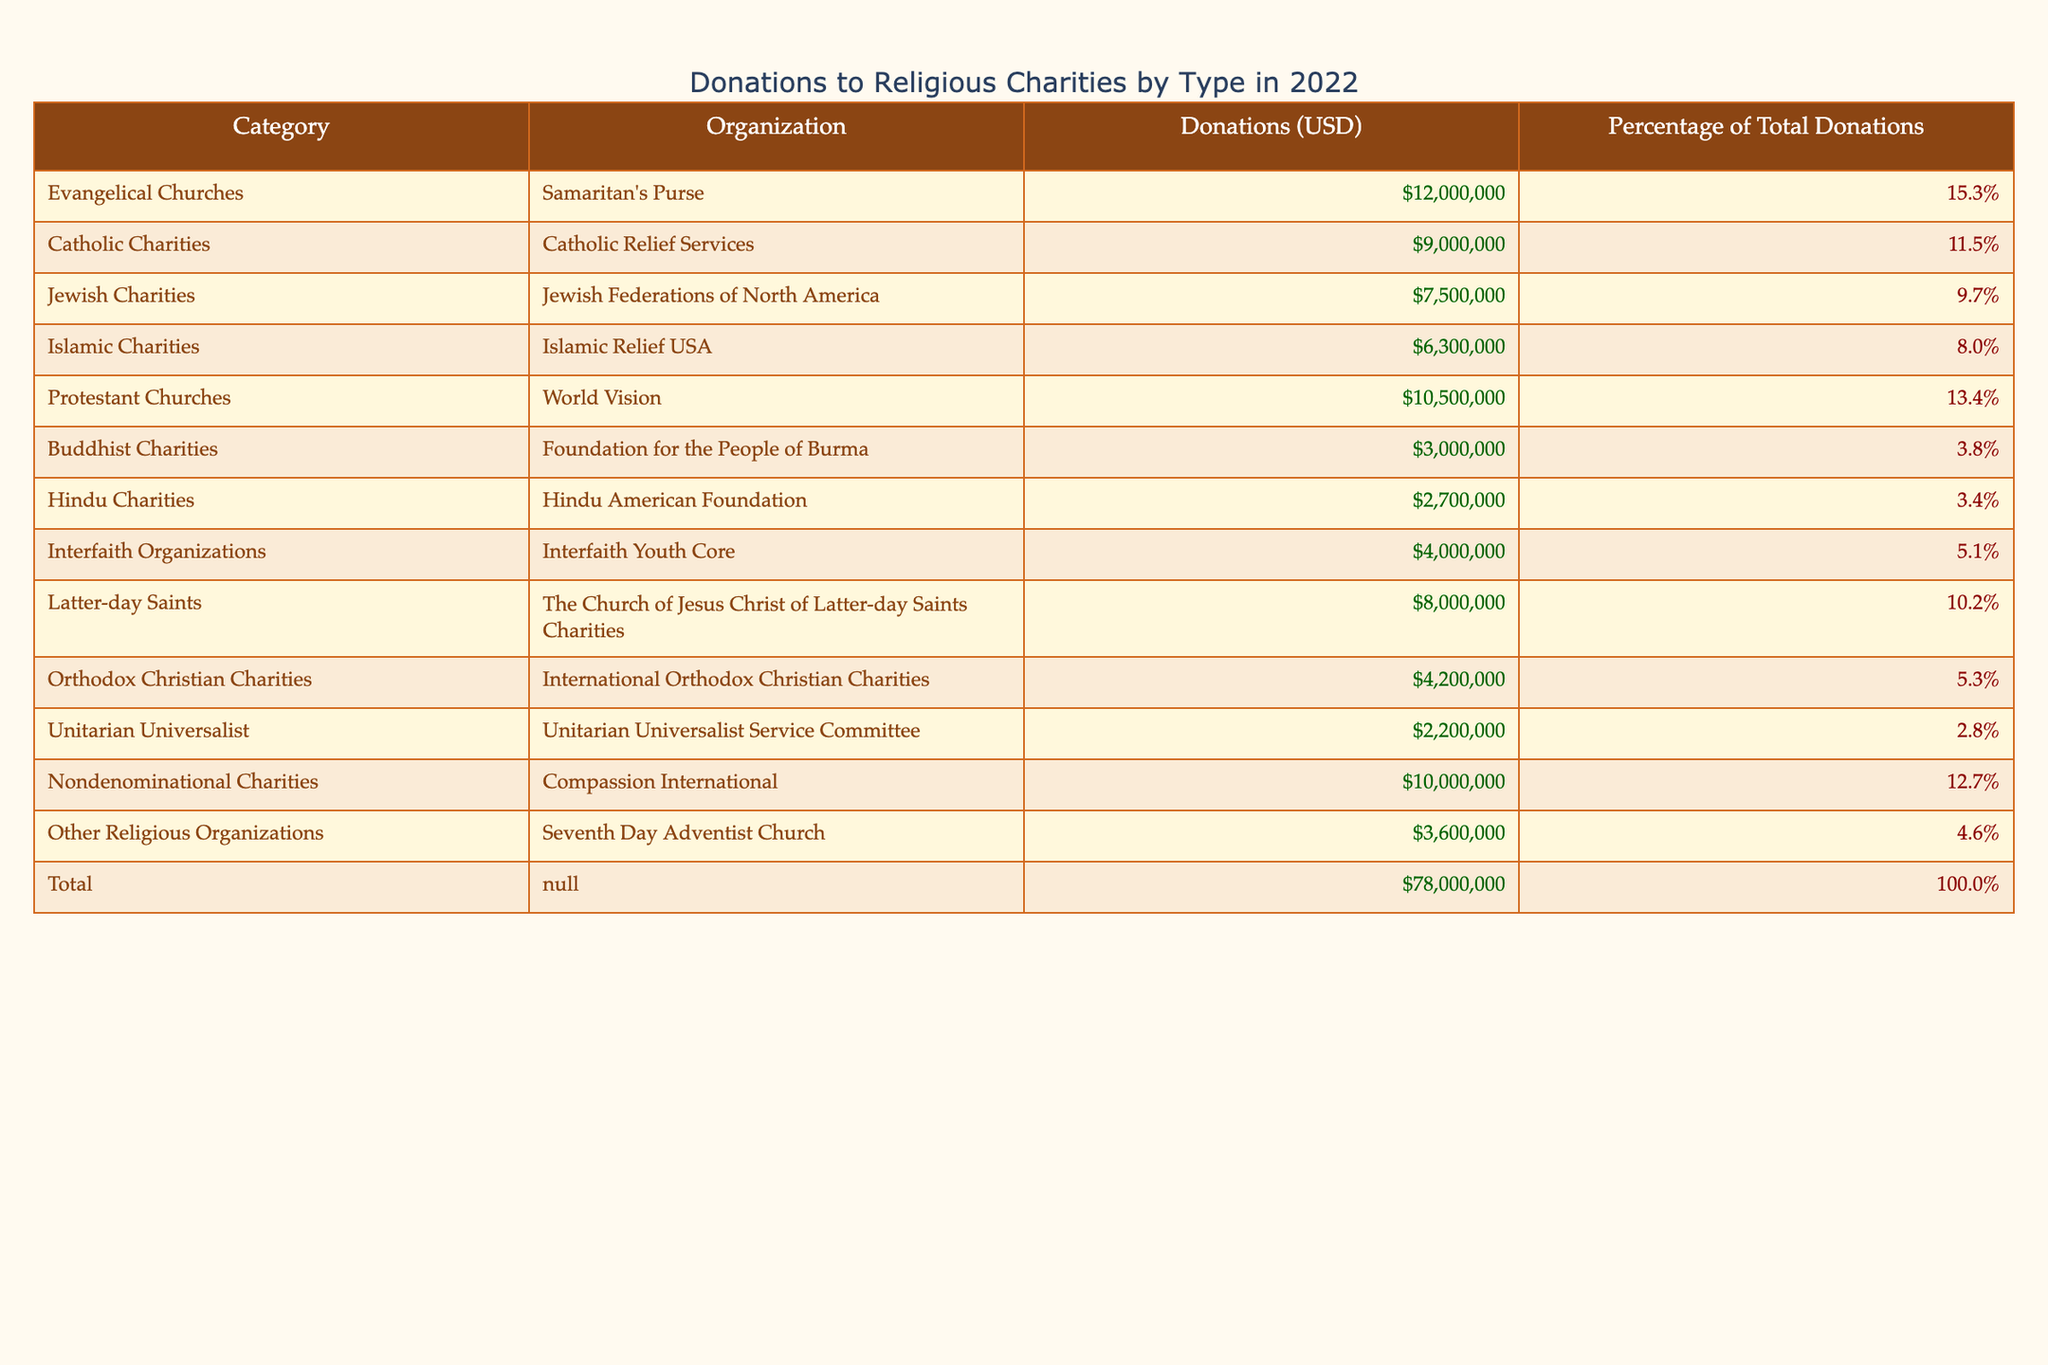What organization received the highest donations? The table shows various organizations along with their corresponding donation amounts. By comparing the "Donations (USD)" column, it is clear that "Samaritan's Purse" received the highest amount at 12,000,000 USD.
Answer: Samaritan's Purse What percentage of total donations did "Jewish Federations of North America" receive? The percentage of total donations for "Jewish Federations of North America" is explicitly listed in the table as 9.7%.
Answer: 9.7% Did the total donations to Protestant Churches exceed 10 million USD? The table lists the donations for "World Vision" under Protestant Churches as 10,500,000 USD, which exceeds 10 million USD.
Answer: Yes Which category of charities received the lowest donations? From the table, "Unitarian Universalist" received the lowest donations with 2,200,000 USD, making it the category with the least financial support.
Answer: Unitarian Universalist What is the total amount of donations received by all Islamic Charities? The table indicates that "Islamic Relief USA" is the only entry for Islamic Charities, receiving 6,300,000 USD. Therefore, the total donations for this category is simply that amount.
Answer: 6,300,000 USD What is the difference in donations between Evangelical Churches and Catholic Charities? The donations to Evangelical Churches ("Samaritan's Purse") total 12,000,000 USD, while those to Catholic Charities ("Catholic Relief Services") total 9,000,000 USD. Calculating the difference: 12,000,000 - 9,000,000 = 3,000,000 USD.
Answer: 3,000,000 USD What is the average donation amount for the Buddhist and Hindu Charities combined? For Buddhist Charities, the donation is 3,000,000 USD and for Hindu Charities, it is 2,700,000 USD. Adding these amounts: 3,000,000 + 2,700,000 = 5,700,000 USD. There are 2 organizations, so the average is 5,700,000 / 2 = 2,850,000 USD.
Answer: 2,850,000 USD Is it true that Latter-day Saints Charities received more donations than Buddhist Charities? Comparing the donations, Latter-day Saints Charities received 8,000,000 USD while Buddhist Charities received only 3,000,000 USD. Thus, it is true that Latter-day Saints Charities received more.
Answer: Yes What percentage of total donations did Nondenominational Charities receive compared to the total donations? Nondenominational Charities received 10,000,000 USD, and the total donations amount to 78,000,000 USD. To find the percentage: (10,000,000 / 78,000,000) * 100 = 12.82%, which rounds to approximately 12.7% as stated in the table.
Answer: 12.7% 